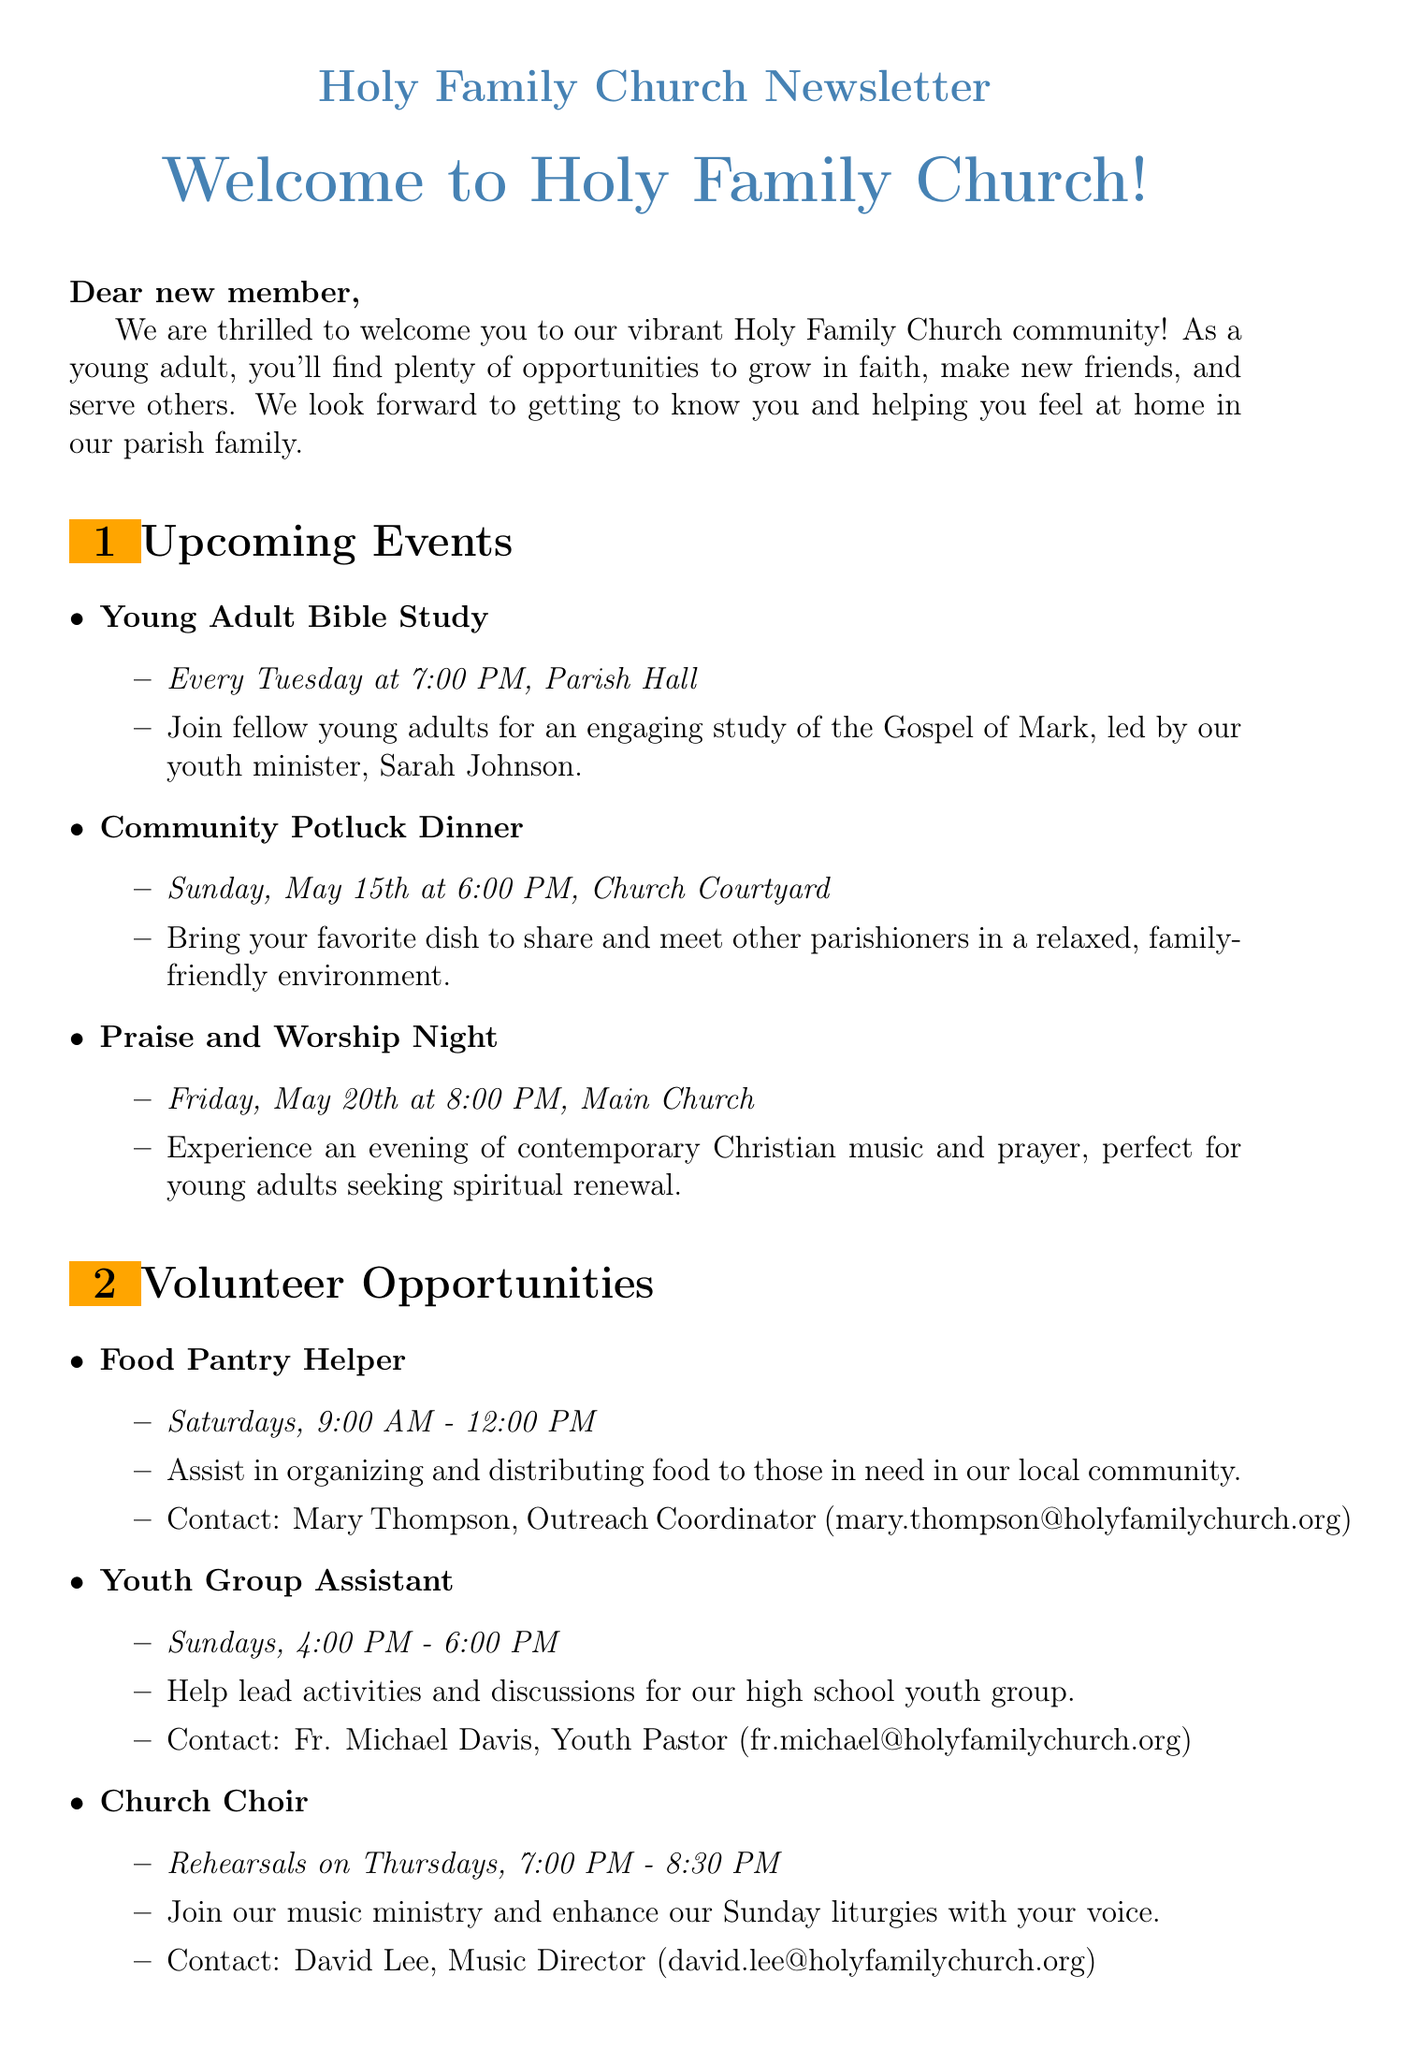What is the title of the welcome message? The title of the welcome message is found at the beginning of the document, addressing new members.
Answer: Welcome to Holy Family Church! When is the Young Adult Bible Study held? The specific details about the Young Adult Bible Study's schedule are included in the upcoming events section.
Answer: Every Tuesday at 7:00 PM Where is the Community Potluck Dinner located? The location of the Community Potluck Dinner is provided in the description of the event.
Answer: Church Courtyard Who should I contact for volunteering as a Food Pantry Helper? The contact information for volunteering is included in the details for the Food Pantry Helper role.
Answer: Mary Thompson, Outreach Coordinator How often are Church Choir rehearsals? The document specifies the schedule for the Church Choir, stating how often they meet.
Answer: Thursdays What type of events are included for young adults? The document lists different types of events specifically designed for young adults, showcasing their relevance.
Answer: Bible Study, Potluck Dinner, Worship Night What is the website for Holy Family Church? The website information is mentioned in the section about getting involved, providing a resource for further inquiries.
Answer: www.holyfamilychurch.org What happens at the Praise and Worship Night? The description of the Praise and Worship Night indicates what participants can expect during the event.
Answer: Contemporary Christian music and prayer How can I connect with Holy Family Church on social media? The social media information provided includes specific platforms and names to connect with the church.
Answer: Facebook, Instagram, Twitter 